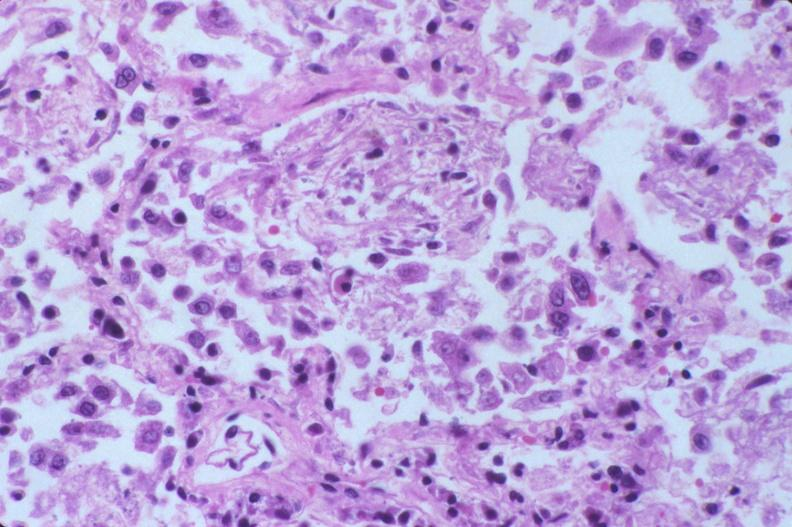s side present?
Answer the question using a single word or phrase. No 